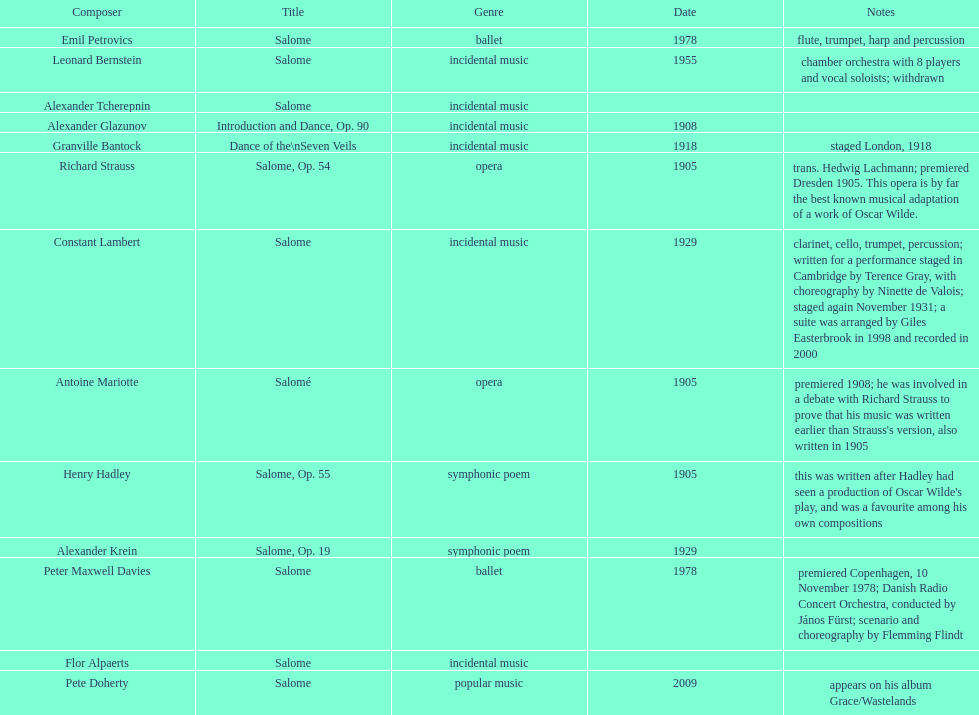Which composer produced his title after 2001? Pete Doherty. 